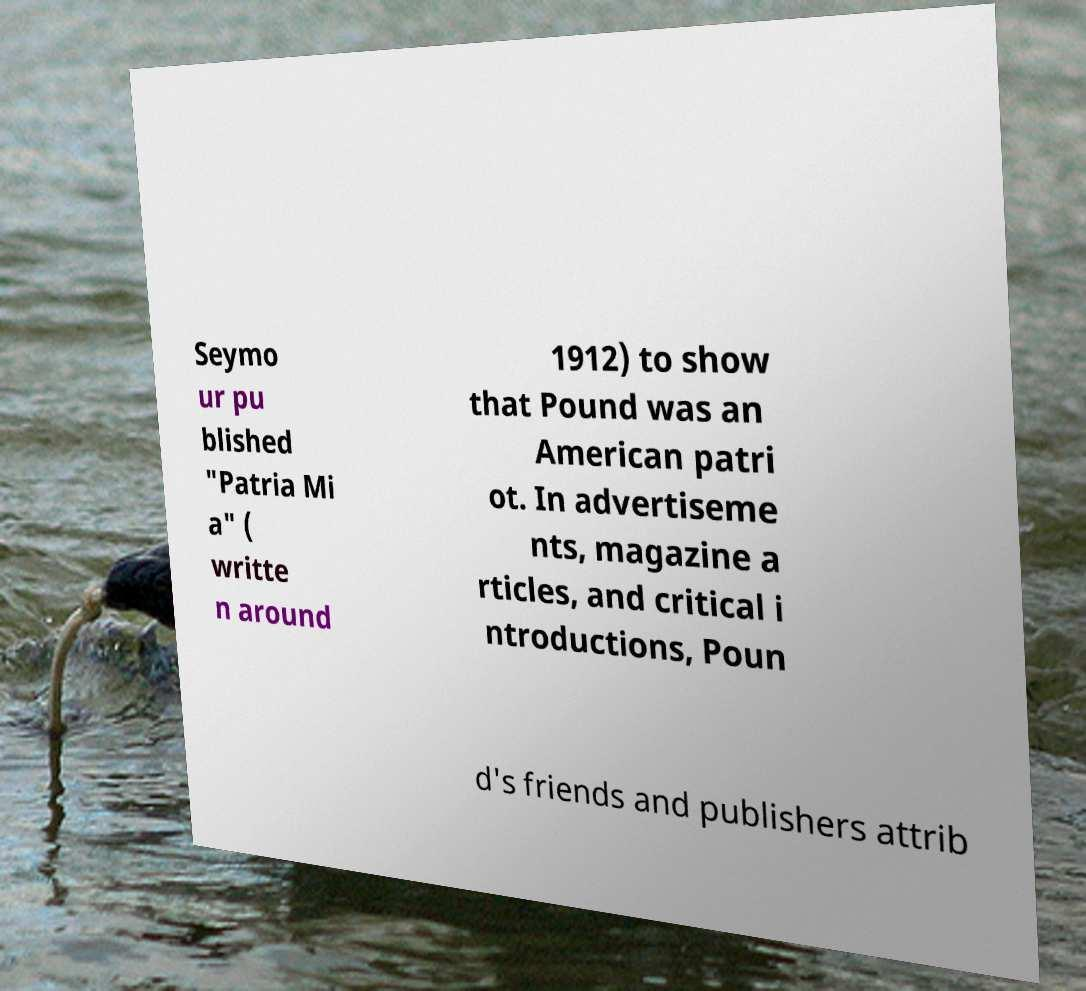There's text embedded in this image that I need extracted. Can you transcribe it verbatim? Seymo ur pu blished "Patria Mi a" ( writte n around 1912) to show that Pound was an American patri ot. In advertiseme nts, magazine a rticles, and critical i ntroductions, Poun d's friends and publishers attrib 